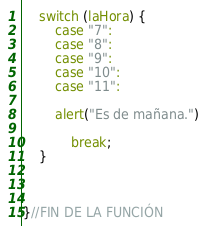Convert code to text. <code><loc_0><loc_0><loc_500><loc_500><_JavaScript_>	switch (laHora) {
        case "7":
        case "8":
        case "9":
        case "10":
        case "11":

        alert("Es de mañana.")
        
            break;
    }



}//FIN DE LA FUNCIÓN</code> 